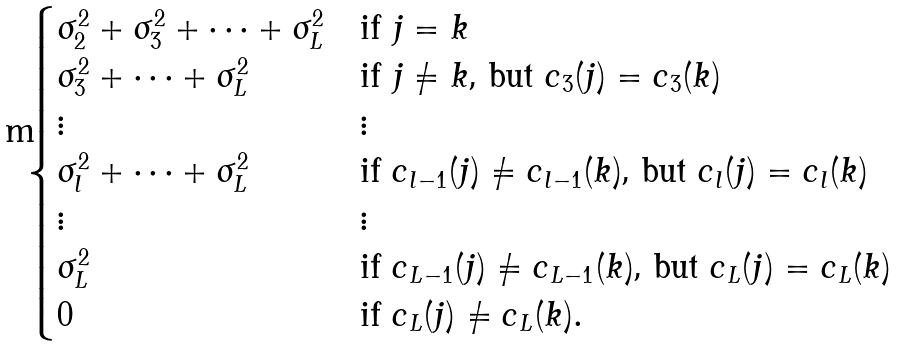<formula> <loc_0><loc_0><loc_500><loc_500>\begin{cases} \sigma _ { 2 } ^ { 2 } + \sigma _ { 3 } ^ { 2 } + \dots + \sigma _ { L } ^ { 2 } & \text {if $j = k$} \\ \sigma _ { 3 } ^ { 2 } + \dots + \sigma _ { L } ^ { 2 } & \text {if $j \not = k$, but $c_{3}(j) = c_{3}(k)$} \\ \vdots & \vdots \\ \sigma _ { l } ^ { 2 } + \dots + \sigma _ { L } ^ { 2 } & \text {if $c_{l-1}(j) \not = c_{l-1}(k)$, but $c_{l}(j) = c_{l}(k)$} \\ \vdots & \vdots \\ \sigma _ { L } ^ { 2 } & \text {if $c_{L-1}(j) \not = c_{L-1}(k)$, but $c_{L}(j) = c_{L}(k)$} \\ 0 & \text {if $c_{L}(j) \not = c_{L}(k).$} \end{cases}</formula> 